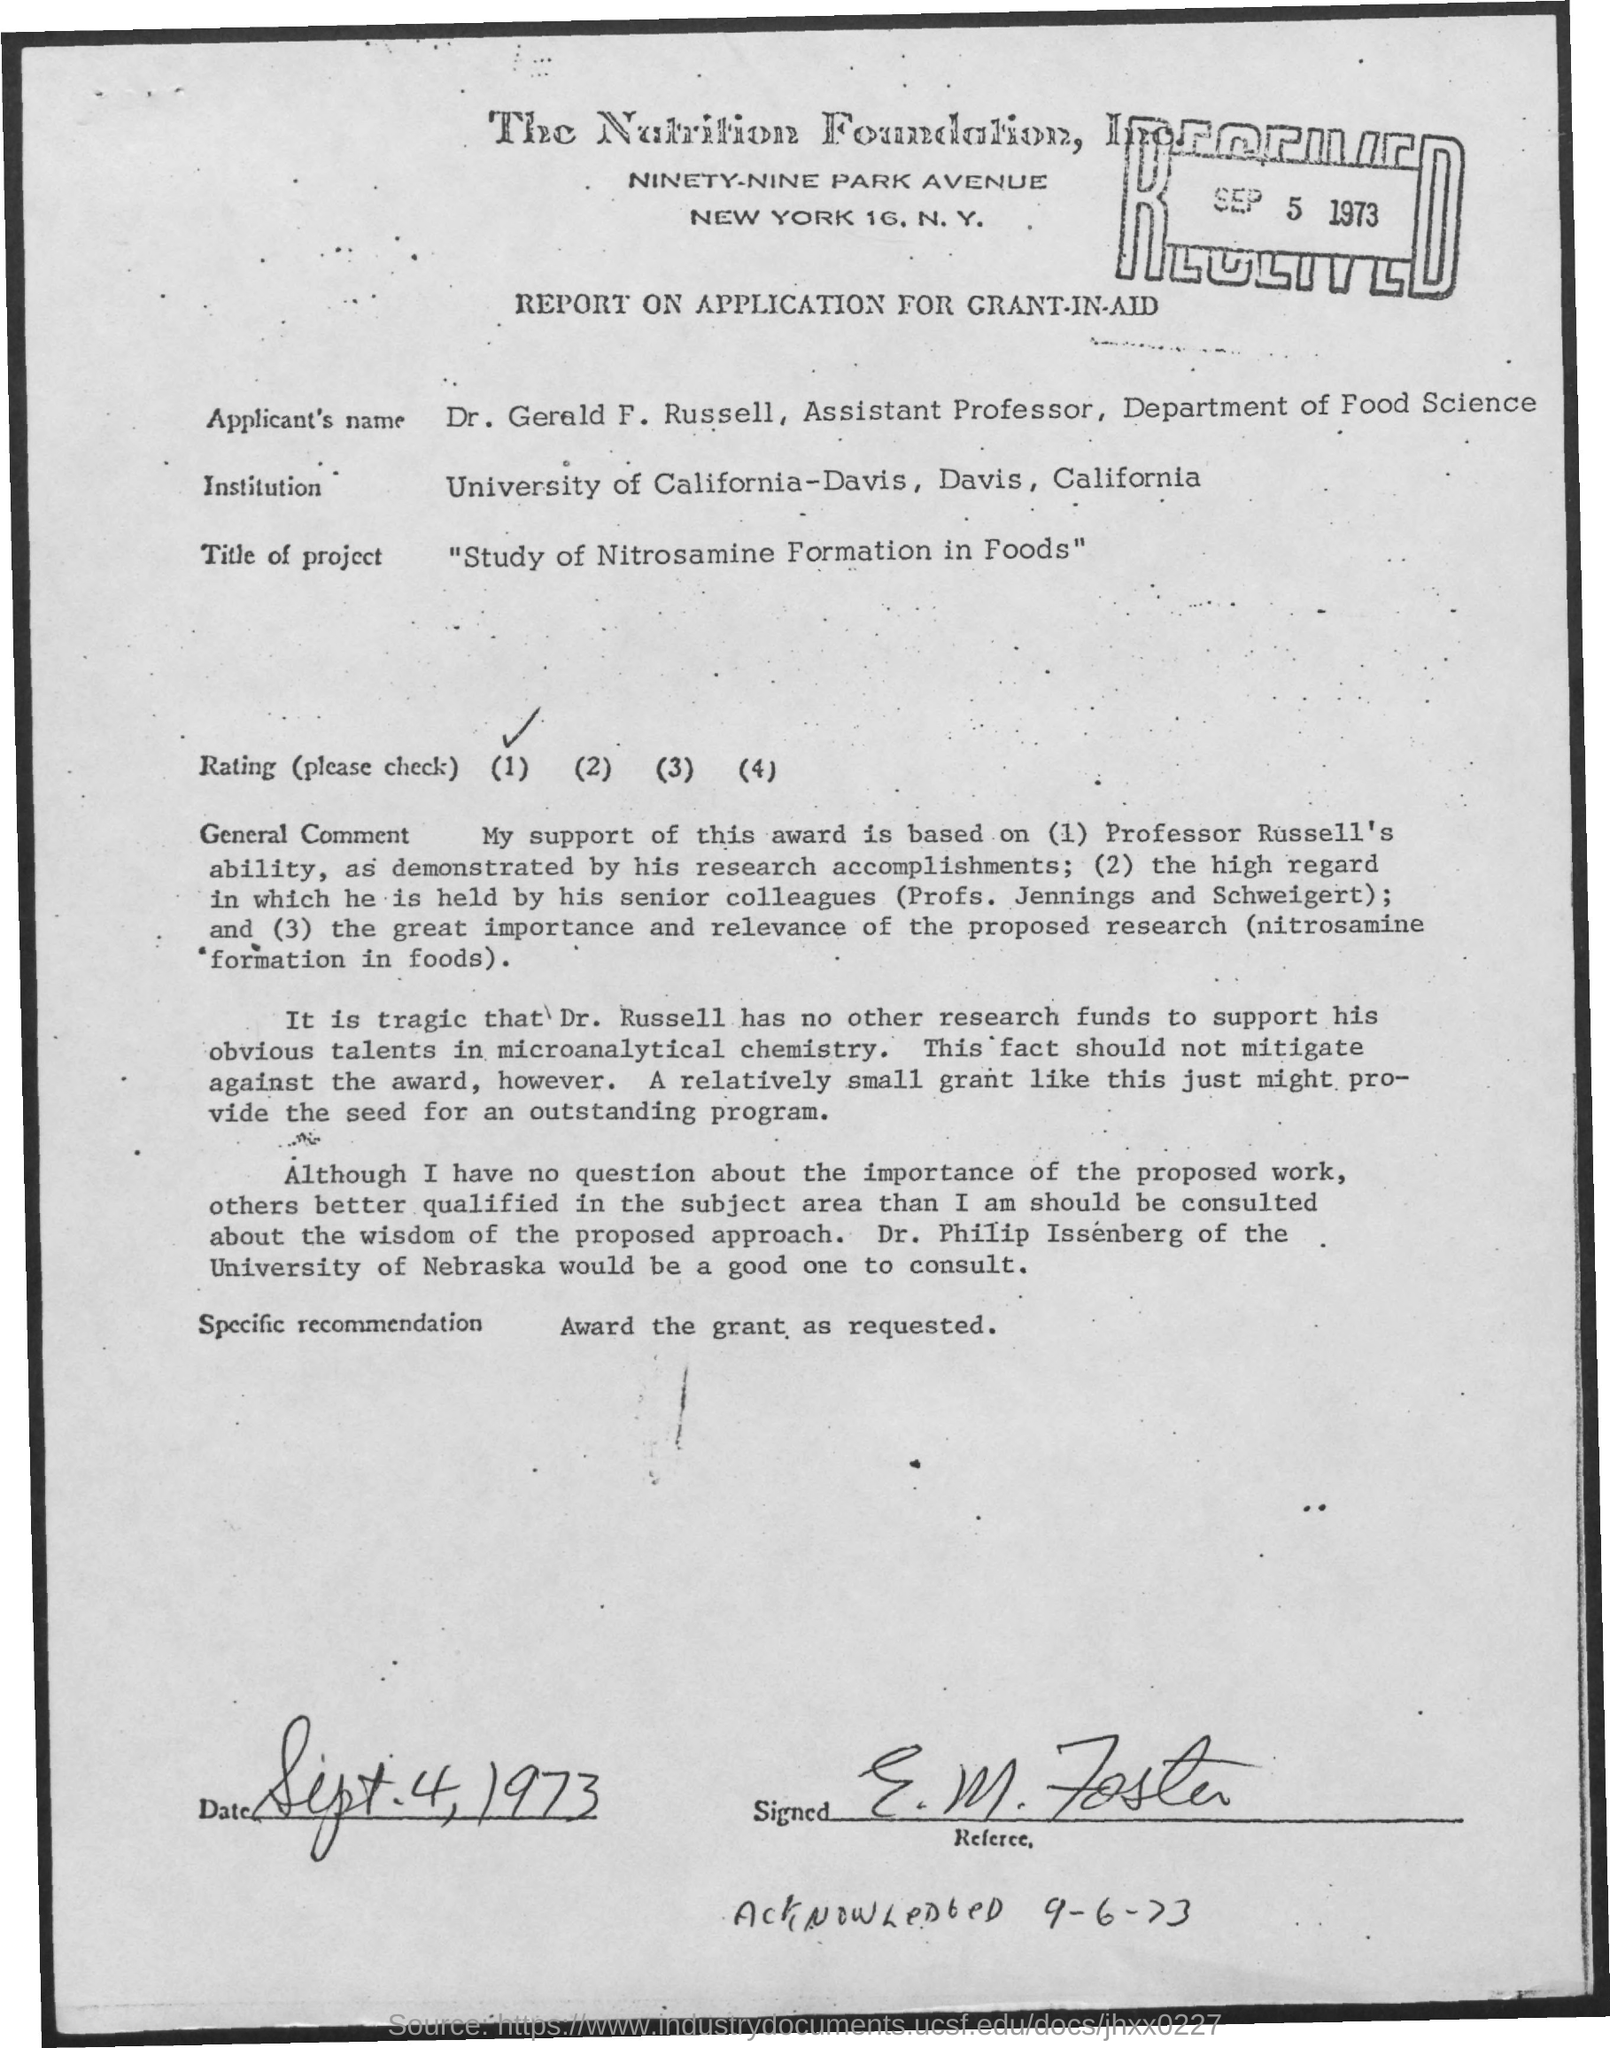Identify some key points in this picture. The applicant's name is Dr. Gerald F. Russell. The date mentioned at the top of the document is September 5, 1973. The title of the project is "A Study of Nitrosamine Formation in Foods. 